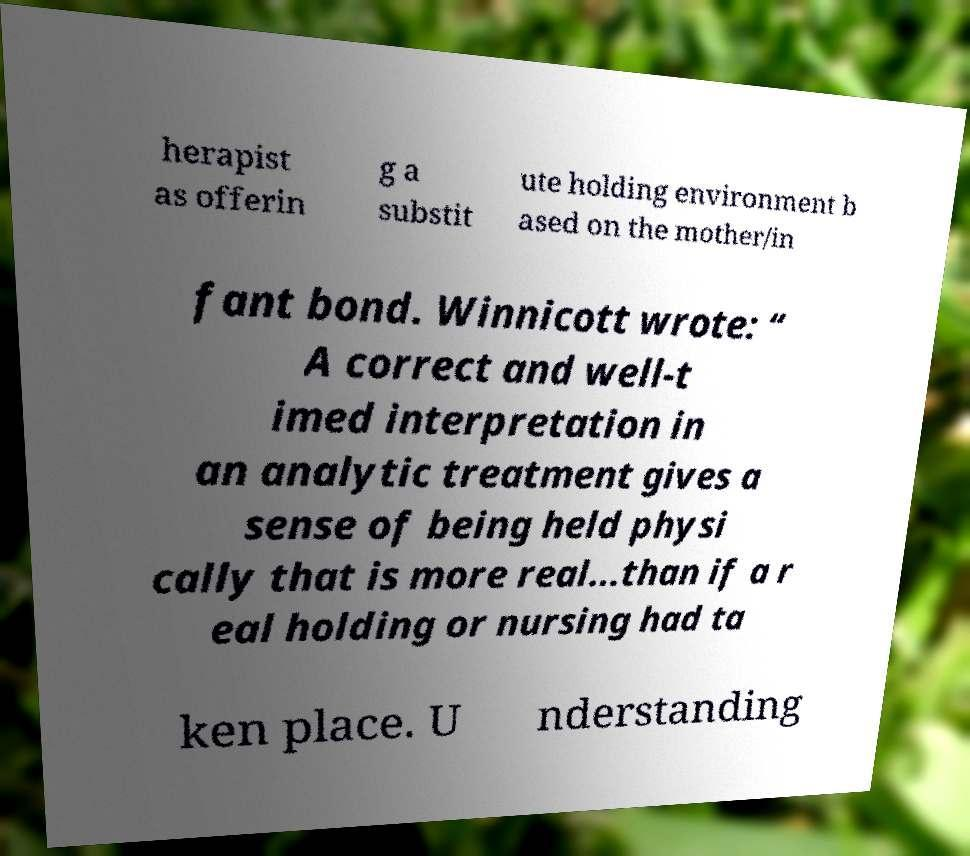I need the written content from this picture converted into text. Can you do that? herapist as offerin g a substit ute holding environment b ased on the mother/in fant bond. Winnicott wrote: “ A correct and well-t imed interpretation in an analytic treatment gives a sense of being held physi cally that is more real...than if a r eal holding or nursing had ta ken place. U nderstanding 